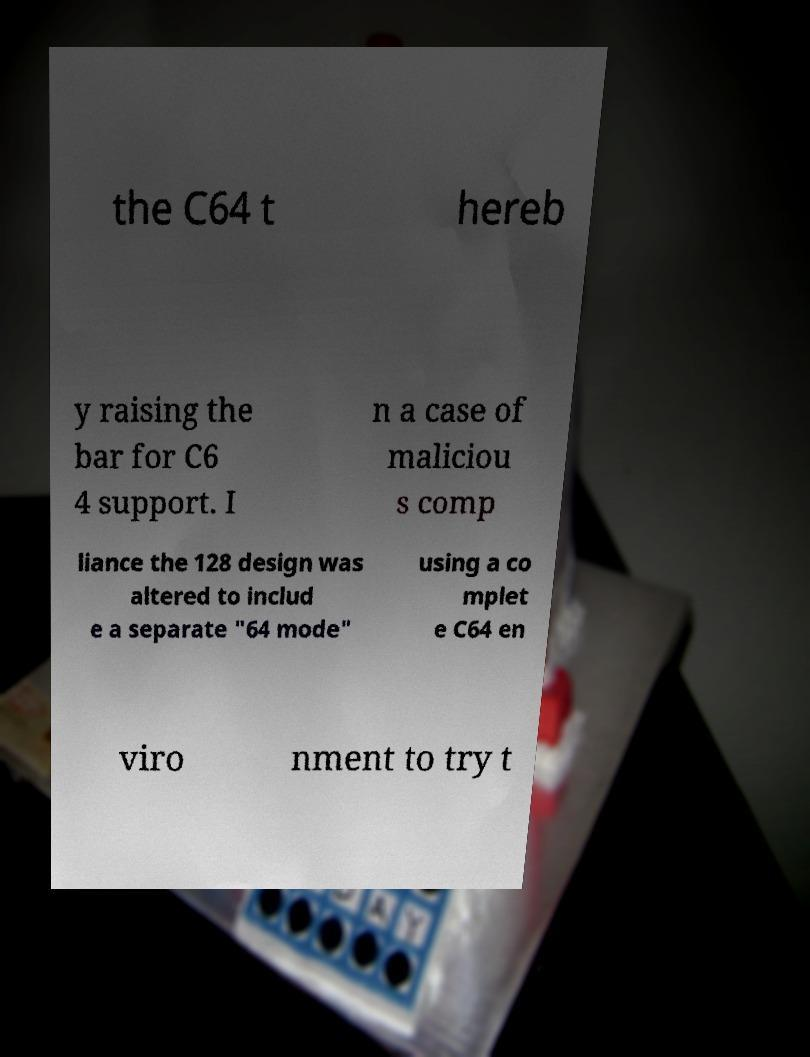What messages or text are displayed in this image? I need them in a readable, typed format. the C64 t hereb y raising the bar for C6 4 support. I n a case of maliciou s comp liance the 128 design was altered to includ e a separate "64 mode" using a co mplet e C64 en viro nment to try t 